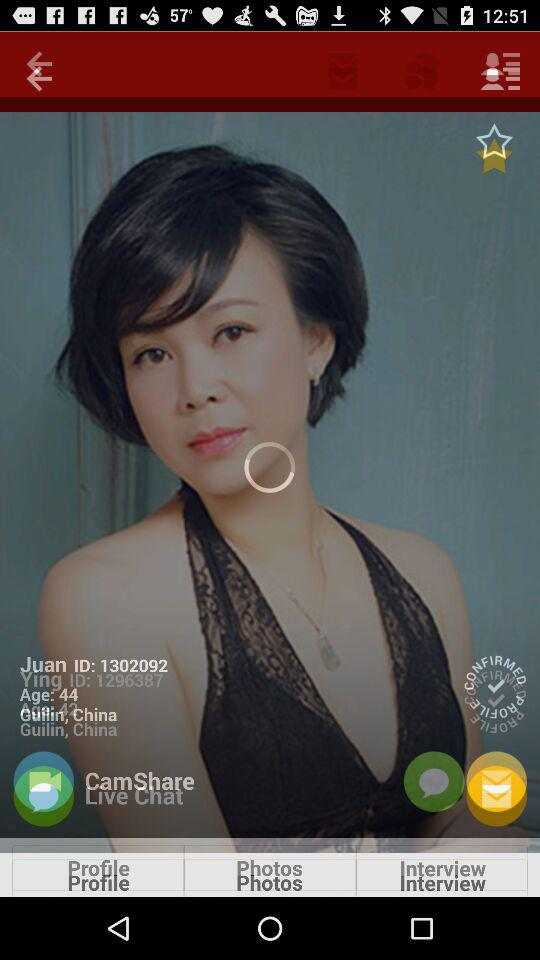When was the interview conducted?
When the provided information is insufficient, respond with <no answer>. <no answer> 